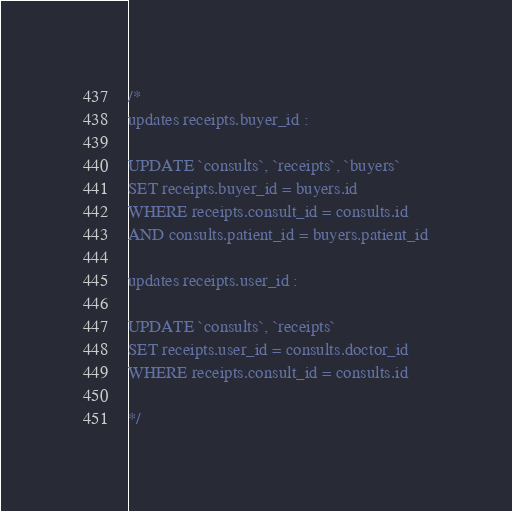Convert code to text. <code><loc_0><loc_0><loc_500><loc_500><_SQL_>/* 
updates receipts.buyer_id :

UPDATE `consults`, `receipts`, `buyers`
SET receipts.buyer_id = buyers.id
WHERE receipts.consult_id = consults.id 
AND consults.patient_id = buyers.patient_id

updates receipts.user_id :

UPDATE `consults`, `receipts`
SET receipts.user_id = consults.doctor_id
WHERE receipts.consult_id = consults.id 

*/</code> 